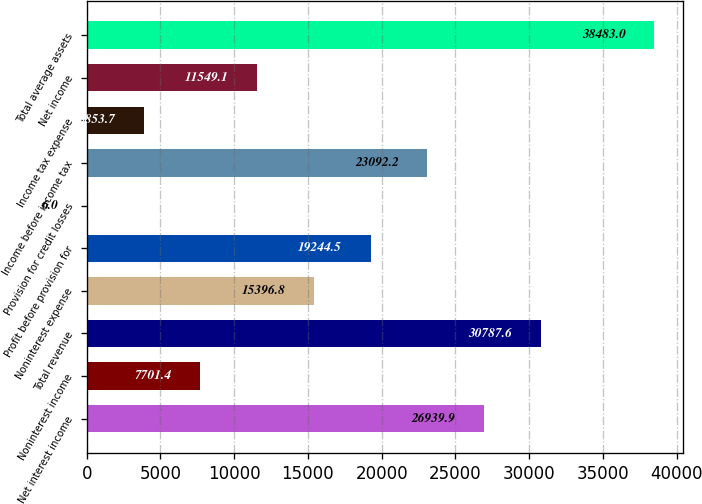<chart> <loc_0><loc_0><loc_500><loc_500><bar_chart><fcel>Net interest income<fcel>Noninterest income<fcel>Total revenue<fcel>Noninterest expense<fcel>Profit before provision for<fcel>Provision for credit losses<fcel>Income before income tax<fcel>Income tax expense<fcel>Net income<fcel>Total average assets<nl><fcel>26939.9<fcel>7701.4<fcel>30787.6<fcel>15396.8<fcel>19244.5<fcel>6<fcel>23092.2<fcel>3853.7<fcel>11549.1<fcel>38483<nl></chart> 